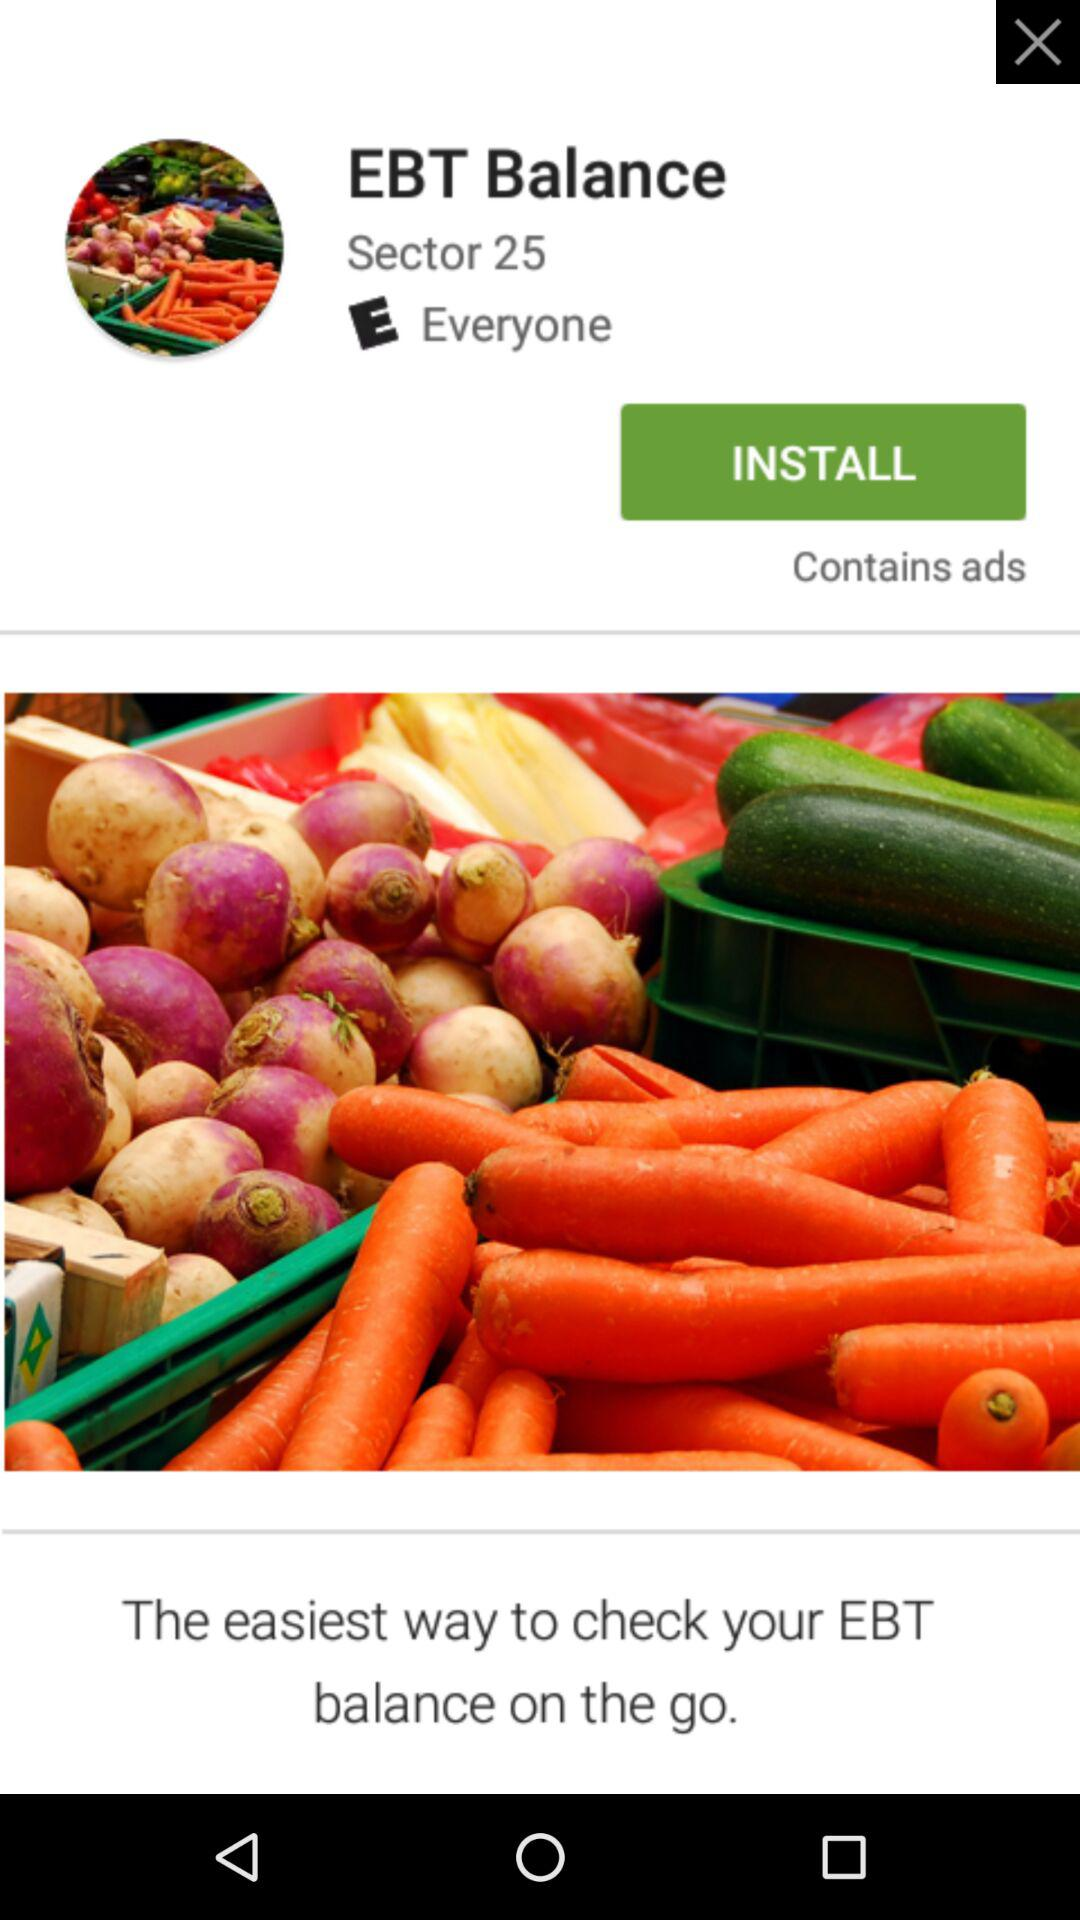What is the name of the application? The name of the application is "EBT Balance". 